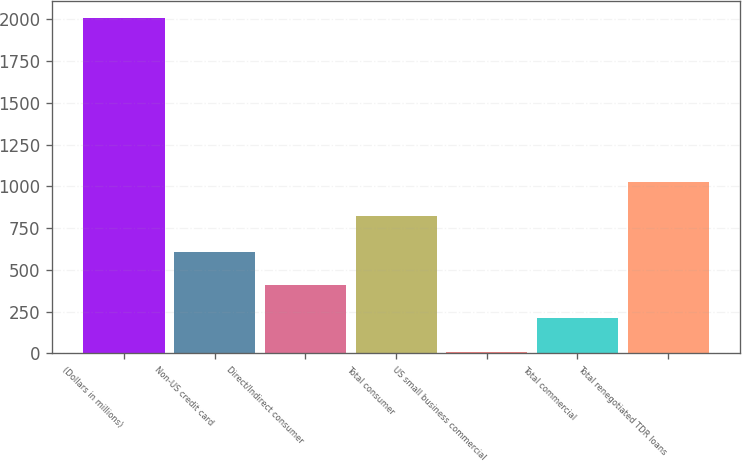Convert chart. <chart><loc_0><loc_0><loc_500><loc_500><bar_chart><fcel>(Dollars in millions)<fcel>Non-US credit card<fcel>Direct/Indirect consumer<fcel>Total consumer<fcel>US small business commercial<fcel>Total commercial<fcel>Total renegotiated TDR loans<nl><fcel>2009<fcel>610.4<fcel>410.6<fcel>824<fcel>11<fcel>210.8<fcel>1023.8<nl></chart> 